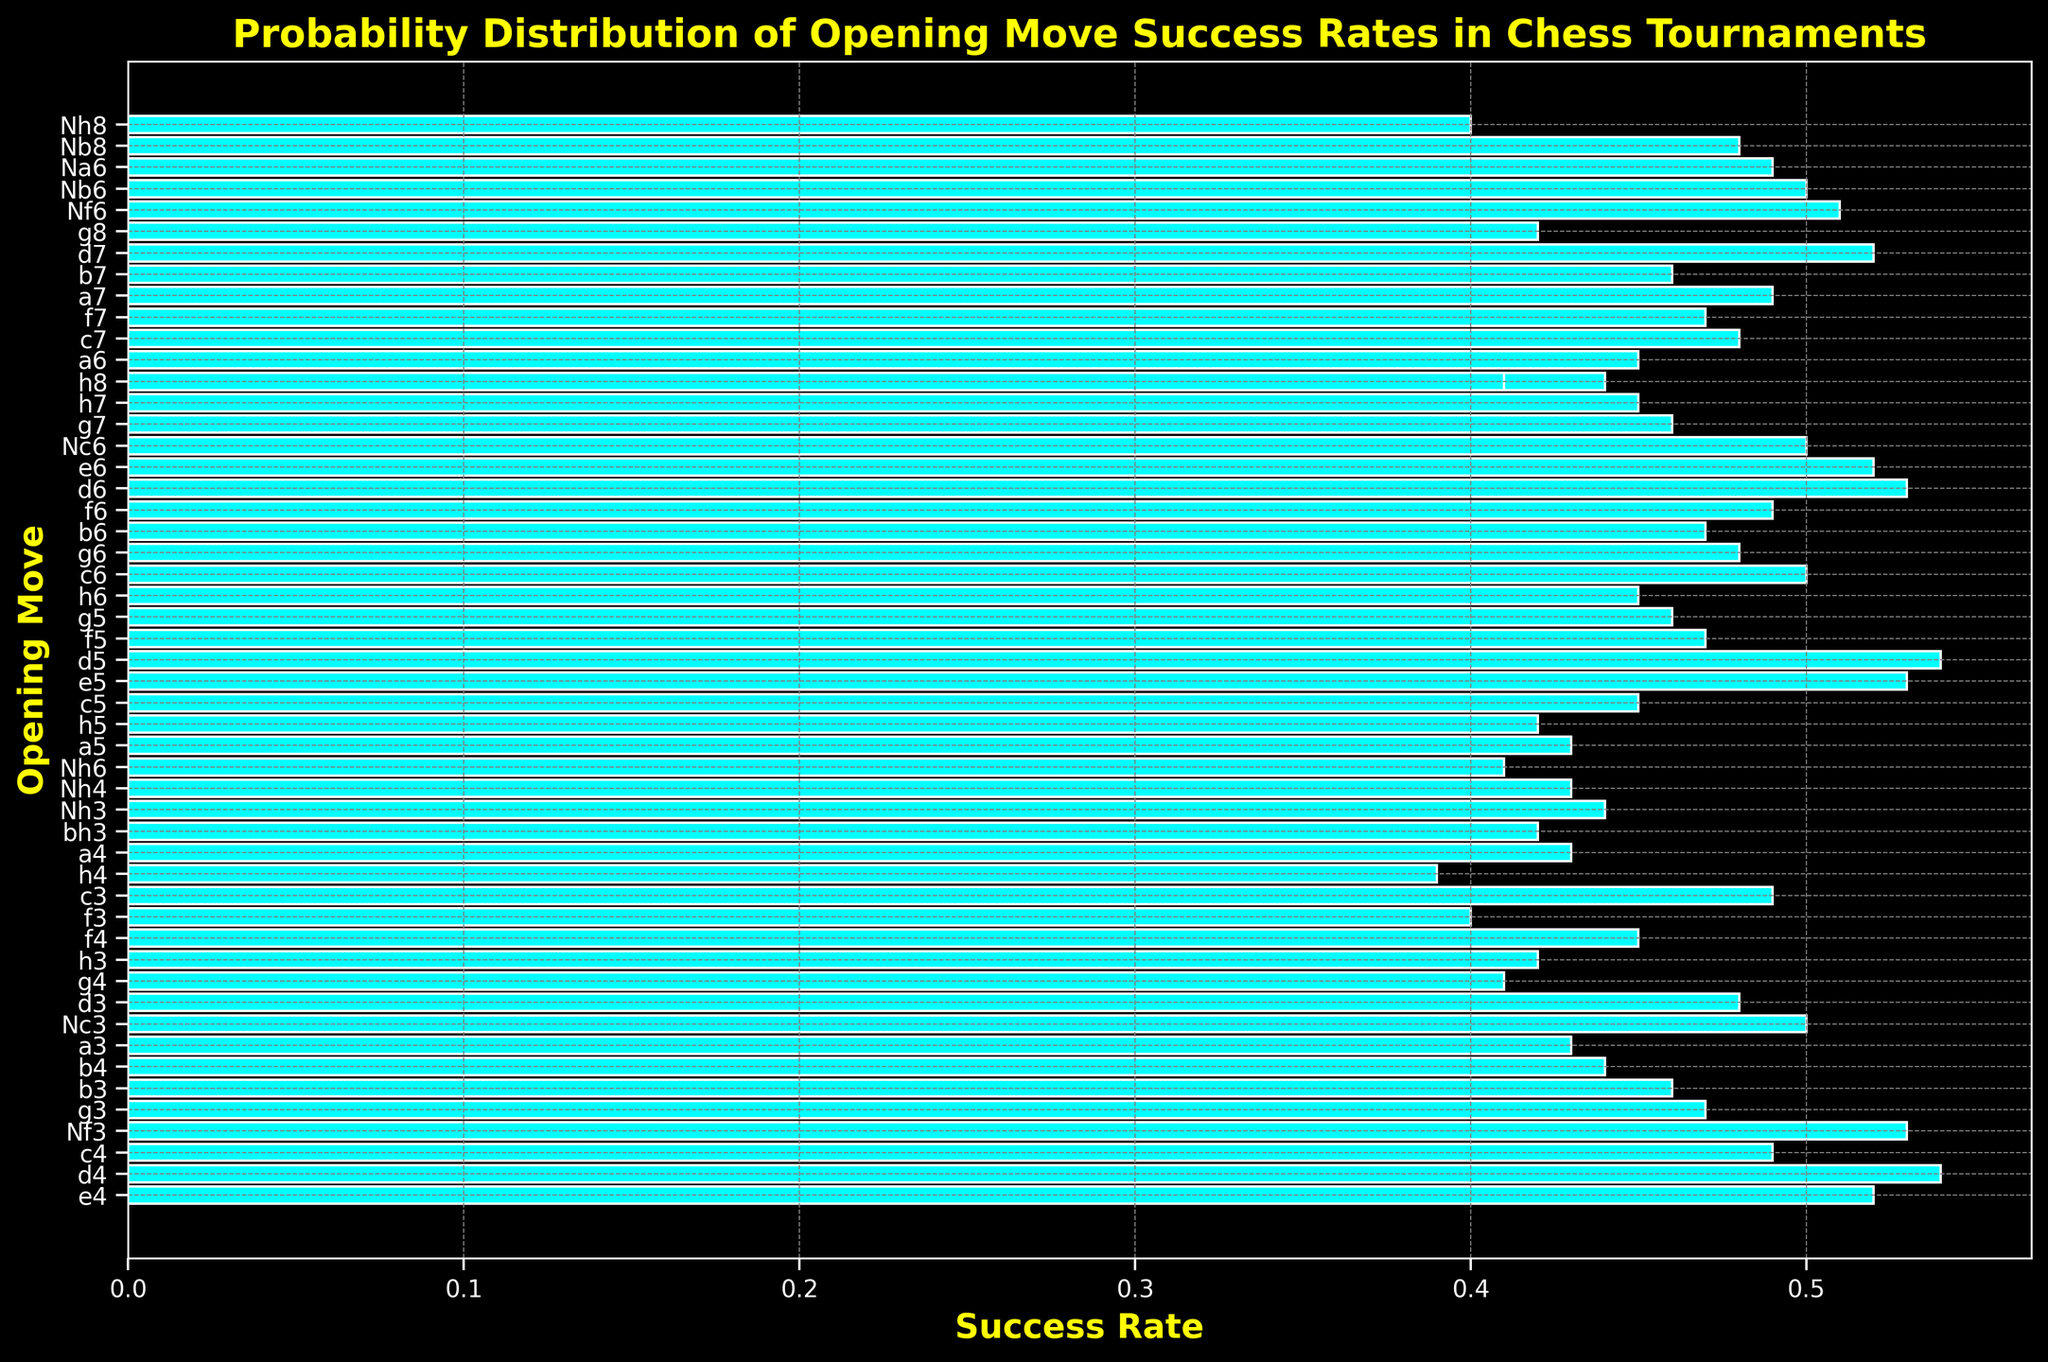Which opening move has the highest success rate? The figure shows various opening moves along with their success rates. The move with the highest bar will indicate the highest success rate.
Answer: d4 Which opening move has the lowest success rate? The figure shows different opening moves with their success rates. The lowest bar represents the move with the lowest success rate.
Answer: h4 What is the difference in success rates between 'e4' and 'd4'? To find the difference, locate the success rates of 'e4' and 'd4', then subtract the smaller value from the larger one: 0.54 - 0.52 = 0.02.
Answer: 0.02 How many opening moves have a success rate of 0.50 or higher? Count the number of bars that reach or exceed the 0.50 mark. Moves such as 'e4', 'd4', 'Nf3', 'Nc3', 'c3', 'd5', and 'Nc6' meet this criterion.
Answer: 8 moves Is the success rate of ‘Nf3’ greater than that of ‘Nc3’? Compare the heights of the bars for 'Nf3' and 'Nc3'. ‘Nf3’ has a success rate of 0.53, while 'Nc3' has a success rate of 0.50.
Answer: Yes Calculate the average success rate of the moves 'e4', 'd4', 'Nf3', and 'Nc3'. Add the success rates of 'e4' (0.52), 'd4' (0.54), 'Nf3' (0.53), and 'Nc3' (0.50), then divide by 4: (0.52 + 0.54 + 0.53 + 0.50) / 4 = 0.5225.
Answer: 0.5225 Which opening has a success rate closest to 0.45? Identify the bars closest to the 0.45 mark. 'f4', 'a5', 'h7', 'h6', and 'g5' are all around 0.45. Among them, 'f4', 'a5', 'h7', 'b4', and 'Nh3' have a success rate of exactly 0.45.
Answer: f4, a5, h7, h6, c3 Which opening move has a success rate equal to 'd4'? Observe the bar for 'd4' and find bars of the same height. Both 'd5' and 'd4' have the same success rate of 0.54.
Answer: d5 Are there more opening moves with a success rate above 0.50 or below 0.50? Count the number of bars above and below the 0.50 mark. Moves such as 'e5', 'd4', 'd5', and some others are above 0.50, the rest are mostly below.
Answer: Below 0.50 